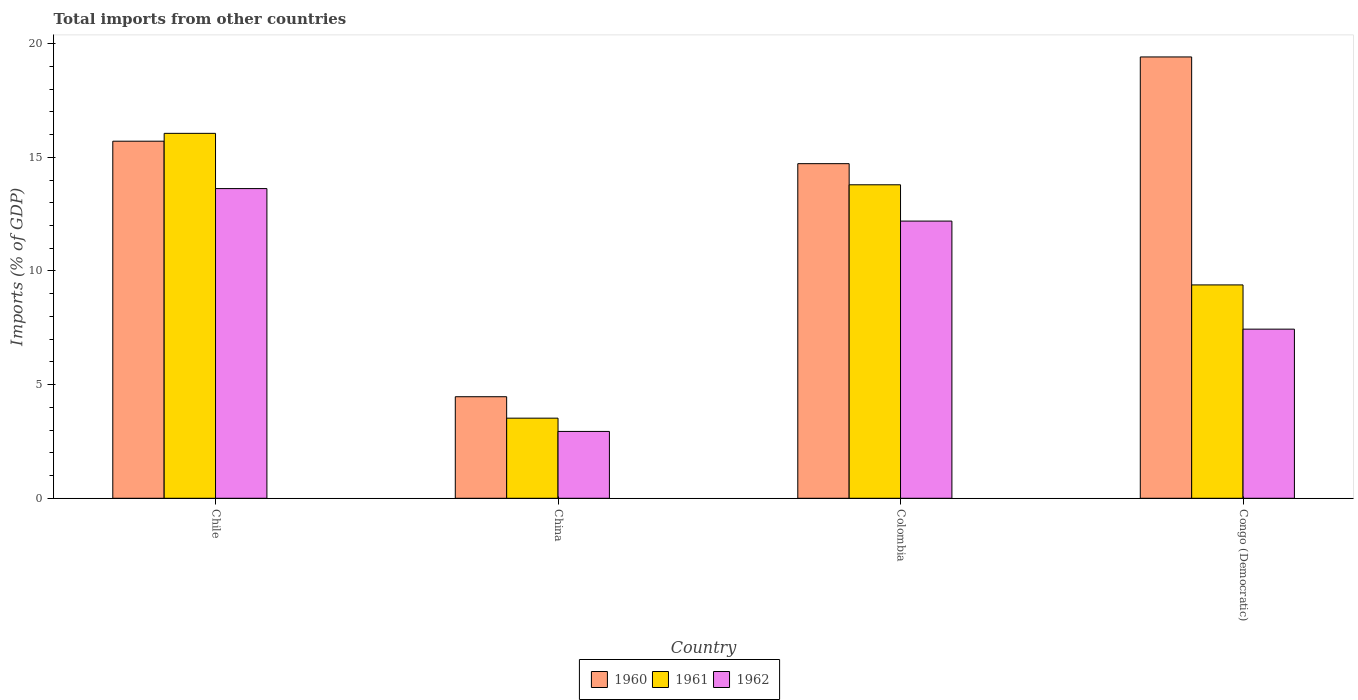How many different coloured bars are there?
Your answer should be compact. 3. Are the number of bars per tick equal to the number of legend labels?
Offer a very short reply. Yes. Are the number of bars on each tick of the X-axis equal?
Give a very brief answer. Yes. How many bars are there on the 2nd tick from the left?
Your answer should be very brief. 3. How many bars are there on the 1st tick from the right?
Offer a very short reply. 3. What is the total imports in 1960 in Colombia?
Your response must be concise. 14.72. Across all countries, what is the maximum total imports in 1960?
Give a very brief answer. 19.42. Across all countries, what is the minimum total imports in 1960?
Provide a succinct answer. 4.47. In which country was the total imports in 1961 maximum?
Ensure brevity in your answer.  Chile. In which country was the total imports in 1961 minimum?
Provide a short and direct response. China. What is the total total imports in 1960 in the graph?
Offer a terse response. 54.32. What is the difference between the total imports in 1961 in Chile and that in Colombia?
Make the answer very short. 2.26. What is the difference between the total imports in 1962 in Congo (Democratic) and the total imports in 1961 in China?
Your answer should be compact. 3.92. What is the average total imports in 1962 per country?
Offer a terse response. 9.05. What is the difference between the total imports of/in 1961 and total imports of/in 1960 in China?
Offer a terse response. -0.94. What is the ratio of the total imports in 1962 in China to that in Congo (Democratic)?
Provide a succinct answer. 0.4. What is the difference between the highest and the second highest total imports in 1961?
Keep it short and to the point. 6.67. What is the difference between the highest and the lowest total imports in 1961?
Your response must be concise. 12.53. Is it the case that in every country, the sum of the total imports in 1961 and total imports in 1962 is greater than the total imports in 1960?
Make the answer very short. No. How many bars are there?
Provide a short and direct response. 12. How many countries are there in the graph?
Offer a very short reply. 4. Are the values on the major ticks of Y-axis written in scientific E-notation?
Keep it short and to the point. No. What is the title of the graph?
Your answer should be compact. Total imports from other countries. Does "2004" appear as one of the legend labels in the graph?
Your answer should be very brief. No. What is the label or title of the Y-axis?
Your answer should be very brief. Imports (% of GDP). What is the Imports (% of GDP) in 1960 in Chile?
Give a very brief answer. 15.71. What is the Imports (% of GDP) in 1961 in Chile?
Give a very brief answer. 16.06. What is the Imports (% of GDP) of 1962 in Chile?
Provide a short and direct response. 13.62. What is the Imports (% of GDP) in 1960 in China?
Offer a very short reply. 4.47. What is the Imports (% of GDP) in 1961 in China?
Keep it short and to the point. 3.52. What is the Imports (% of GDP) in 1962 in China?
Offer a terse response. 2.94. What is the Imports (% of GDP) of 1960 in Colombia?
Keep it short and to the point. 14.72. What is the Imports (% of GDP) in 1961 in Colombia?
Give a very brief answer. 13.79. What is the Imports (% of GDP) of 1962 in Colombia?
Keep it short and to the point. 12.2. What is the Imports (% of GDP) in 1960 in Congo (Democratic)?
Your response must be concise. 19.42. What is the Imports (% of GDP) of 1961 in Congo (Democratic)?
Your answer should be very brief. 9.39. What is the Imports (% of GDP) of 1962 in Congo (Democratic)?
Offer a very short reply. 7.44. Across all countries, what is the maximum Imports (% of GDP) of 1960?
Offer a terse response. 19.42. Across all countries, what is the maximum Imports (% of GDP) in 1961?
Provide a succinct answer. 16.06. Across all countries, what is the maximum Imports (% of GDP) of 1962?
Keep it short and to the point. 13.62. Across all countries, what is the minimum Imports (% of GDP) in 1960?
Give a very brief answer. 4.47. Across all countries, what is the minimum Imports (% of GDP) of 1961?
Make the answer very short. 3.52. Across all countries, what is the minimum Imports (% of GDP) of 1962?
Your answer should be compact. 2.94. What is the total Imports (% of GDP) of 1960 in the graph?
Offer a very short reply. 54.32. What is the total Imports (% of GDP) in 1961 in the graph?
Give a very brief answer. 42.76. What is the total Imports (% of GDP) of 1962 in the graph?
Your response must be concise. 36.2. What is the difference between the Imports (% of GDP) in 1960 in Chile and that in China?
Provide a succinct answer. 11.24. What is the difference between the Imports (% of GDP) of 1961 in Chile and that in China?
Offer a terse response. 12.53. What is the difference between the Imports (% of GDP) in 1962 in Chile and that in China?
Your answer should be very brief. 10.68. What is the difference between the Imports (% of GDP) of 1960 in Chile and that in Colombia?
Your answer should be very brief. 0.99. What is the difference between the Imports (% of GDP) of 1961 in Chile and that in Colombia?
Your answer should be compact. 2.26. What is the difference between the Imports (% of GDP) of 1962 in Chile and that in Colombia?
Provide a succinct answer. 1.43. What is the difference between the Imports (% of GDP) of 1960 in Chile and that in Congo (Democratic)?
Your response must be concise. -3.71. What is the difference between the Imports (% of GDP) in 1961 in Chile and that in Congo (Democratic)?
Keep it short and to the point. 6.67. What is the difference between the Imports (% of GDP) in 1962 in Chile and that in Congo (Democratic)?
Offer a very short reply. 6.18. What is the difference between the Imports (% of GDP) of 1960 in China and that in Colombia?
Provide a succinct answer. -10.25. What is the difference between the Imports (% of GDP) of 1961 in China and that in Colombia?
Offer a very short reply. -10.27. What is the difference between the Imports (% of GDP) in 1962 in China and that in Colombia?
Your response must be concise. -9.25. What is the difference between the Imports (% of GDP) of 1960 in China and that in Congo (Democratic)?
Keep it short and to the point. -14.95. What is the difference between the Imports (% of GDP) in 1961 in China and that in Congo (Democratic)?
Give a very brief answer. -5.86. What is the difference between the Imports (% of GDP) in 1962 in China and that in Congo (Democratic)?
Keep it short and to the point. -4.5. What is the difference between the Imports (% of GDP) in 1960 in Colombia and that in Congo (Democratic)?
Give a very brief answer. -4.7. What is the difference between the Imports (% of GDP) in 1961 in Colombia and that in Congo (Democratic)?
Offer a terse response. 4.4. What is the difference between the Imports (% of GDP) of 1962 in Colombia and that in Congo (Democratic)?
Your response must be concise. 4.75. What is the difference between the Imports (% of GDP) of 1960 in Chile and the Imports (% of GDP) of 1961 in China?
Your response must be concise. 12.19. What is the difference between the Imports (% of GDP) in 1960 in Chile and the Imports (% of GDP) in 1962 in China?
Offer a very short reply. 12.77. What is the difference between the Imports (% of GDP) of 1961 in Chile and the Imports (% of GDP) of 1962 in China?
Your answer should be very brief. 13.11. What is the difference between the Imports (% of GDP) in 1960 in Chile and the Imports (% of GDP) in 1961 in Colombia?
Give a very brief answer. 1.92. What is the difference between the Imports (% of GDP) in 1960 in Chile and the Imports (% of GDP) in 1962 in Colombia?
Your answer should be compact. 3.51. What is the difference between the Imports (% of GDP) of 1961 in Chile and the Imports (% of GDP) of 1962 in Colombia?
Your answer should be very brief. 3.86. What is the difference between the Imports (% of GDP) of 1960 in Chile and the Imports (% of GDP) of 1961 in Congo (Democratic)?
Provide a short and direct response. 6.32. What is the difference between the Imports (% of GDP) in 1960 in Chile and the Imports (% of GDP) in 1962 in Congo (Democratic)?
Make the answer very short. 8.27. What is the difference between the Imports (% of GDP) in 1961 in Chile and the Imports (% of GDP) in 1962 in Congo (Democratic)?
Your answer should be very brief. 8.61. What is the difference between the Imports (% of GDP) of 1960 in China and the Imports (% of GDP) of 1961 in Colombia?
Your answer should be compact. -9.32. What is the difference between the Imports (% of GDP) in 1960 in China and the Imports (% of GDP) in 1962 in Colombia?
Ensure brevity in your answer.  -7.73. What is the difference between the Imports (% of GDP) of 1961 in China and the Imports (% of GDP) of 1962 in Colombia?
Offer a terse response. -8.67. What is the difference between the Imports (% of GDP) of 1960 in China and the Imports (% of GDP) of 1961 in Congo (Democratic)?
Your answer should be very brief. -4.92. What is the difference between the Imports (% of GDP) of 1960 in China and the Imports (% of GDP) of 1962 in Congo (Democratic)?
Give a very brief answer. -2.97. What is the difference between the Imports (% of GDP) in 1961 in China and the Imports (% of GDP) in 1962 in Congo (Democratic)?
Ensure brevity in your answer.  -3.92. What is the difference between the Imports (% of GDP) of 1960 in Colombia and the Imports (% of GDP) of 1961 in Congo (Democratic)?
Ensure brevity in your answer.  5.33. What is the difference between the Imports (% of GDP) in 1960 in Colombia and the Imports (% of GDP) in 1962 in Congo (Democratic)?
Your response must be concise. 7.28. What is the difference between the Imports (% of GDP) in 1961 in Colombia and the Imports (% of GDP) in 1962 in Congo (Democratic)?
Make the answer very short. 6.35. What is the average Imports (% of GDP) of 1960 per country?
Your answer should be compact. 13.58. What is the average Imports (% of GDP) in 1961 per country?
Your response must be concise. 10.69. What is the average Imports (% of GDP) in 1962 per country?
Your response must be concise. 9.05. What is the difference between the Imports (% of GDP) of 1960 and Imports (% of GDP) of 1961 in Chile?
Provide a succinct answer. -0.35. What is the difference between the Imports (% of GDP) of 1960 and Imports (% of GDP) of 1962 in Chile?
Offer a terse response. 2.08. What is the difference between the Imports (% of GDP) of 1961 and Imports (% of GDP) of 1962 in Chile?
Give a very brief answer. 2.43. What is the difference between the Imports (% of GDP) in 1960 and Imports (% of GDP) in 1961 in China?
Give a very brief answer. 0.94. What is the difference between the Imports (% of GDP) of 1960 and Imports (% of GDP) of 1962 in China?
Offer a terse response. 1.53. What is the difference between the Imports (% of GDP) of 1961 and Imports (% of GDP) of 1962 in China?
Make the answer very short. 0.58. What is the difference between the Imports (% of GDP) of 1960 and Imports (% of GDP) of 1961 in Colombia?
Offer a terse response. 0.93. What is the difference between the Imports (% of GDP) of 1960 and Imports (% of GDP) of 1962 in Colombia?
Offer a very short reply. 2.53. What is the difference between the Imports (% of GDP) in 1961 and Imports (% of GDP) in 1962 in Colombia?
Provide a succinct answer. 1.6. What is the difference between the Imports (% of GDP) in 1960 and Imports (% of GDP) in 1961 in Congo (Democratic)?
Ensure brevity in your answer.  10.03. What is the difference between the Imports (% of GDP) of 1960 and Imports (% of GDP) of 1962 in Congo (Democratic)?
Your answer should be very brief. 11.98. What is the difference between the Imports (% of GDP) of 1961 and Imports (% of GDP) of 1962 in Congo (Democratic)?
Provide a succinct answer. 1.95. What is the ratio of the Imports (% of GDP) in 1960 in Chile to that in China?
Offer a terse response. 3.52. What is the ratio of the Imports (% of GDP) of 1961 in Chile to that in China?
Your response must be concise. 4.56. What is the ratio of the Imports (% of GDP) of 1962 in Chile to that in China?
Provide a short and direct response. 4.63. What is the ratio of the Imports (% of GDP) in 1960 in Chile to that in Colombia?
Make the answer very short. 1.07. What is the ratio of the Imports (% of GDP) of 1961 in Chile to that in Colombia?
Provide a short and direct response. 1.16. What is the ratio of the Imports (% of GDP) of 1962 in Chile to that in Colombia?
Your response must be concise. 1.12. What is the ratio of the Imports (% of GDP) in 1960 in Chile to that in Congo (Democratic)?
Ensure brevity in your answer.  0.81. What is the ratio of the Imports (% of GDP) of 1961 in Chile to that in Congo (Democratic)?
Offer a terse response. 1.71. What is the ratio of the Imports (% of GDP) of 1962 in Chile to that in Congo (Democratic)?
Your answer should be compact. 1.83. What is the ratio of the Imports (% of GDP) of 1960 in China to that in Colombia?
Keep it short and to the point. 0.3. What is the ratio of the Imports (% of GDP) of 1961 in China to that in Colombia?
Your response must be concise. 0.26. What is the ratio of the Imports (% of GDP) of 1962 in China to that in Colombia?
Your answer should be compact. 0.24. What is the ratio of the Imports (% of GDP) of 1960 in China to that in Congo (Democratic)?
Offer a very short reply. 0.23. What is the ratio of the Imports (% of GDP) in 1961 in China to that in Congo (Democratic)?
Provide a short and direct response. 0.38. What is the ratio of the Imports (% of GDP) in 1962 in China to that in Congo (Democratic)?
Your response must be concise. 0.4. What is the ratio of the Imports (% of GDP) of 1960 in Colombia to that in Congo (Democratic)?
Provide a short and direct response. 0.76. What is the ratio of the Imports (% of GDP) in 1961 in Colombia to that in Congo (Democratic)?
Keep it short and to the point. 1.47. What is the ratio of the Imports (% of GDP) in 1962 in Colombia to that in Congo (Democratic)?
Your answer should be very brief. 1.64. What is the difference between the highest and the second highest Imports (% of GDP) in 1960?
Keep it short and to the point. 3.71. What is the difference between the highest and the second highest Imports (% of GDP) of 1961?
Offer a terse response. 2.26. What is the difference between the highest and the second highest Imports (% of GDP) in 1962?
Provide a short and direct response. 1.43. What is the difference between the highest and the lowest Imports (% of GDP) in 1960?
Your answer should be compact. 14.95. What is the difference between the highest and the lowest Imports (% of GDP) in 1961?
Keep it short and to the point. 12.53. What is the difference between the highest and the lowest Imports (% of GDP) of 1962?
Give a very brief answer. 10.68. 